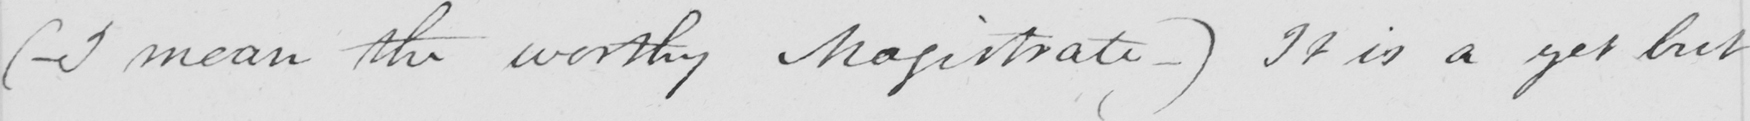What does this handwritten line say? (  _ I mean the worthy Magistrate _  )  It is a yet but 